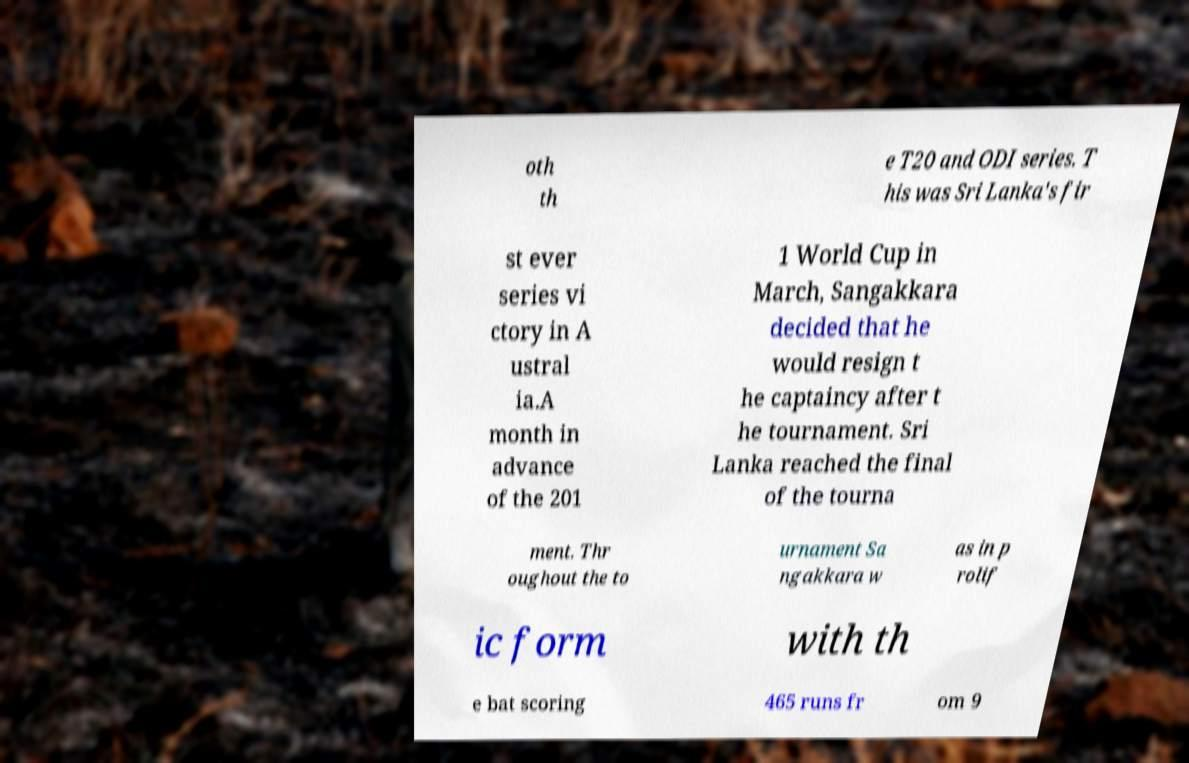For documentation purposes, I need the text within this image transcribed. Could you provide that? oth th e T20 and ODI series. T his was Sri Lanka's fir st ever series vi ctory in A ustral ia.A month in advance of the 201 1 World Cup in March, Sangakkara decided that he would resign t he captaincy after t he tournament. Sri Lanka reached the final of the tourna ment. Thr oughout the to urnament Sa ngakkara w as in p rolif ic form with th e bat scoring 465 runs fr om 9 